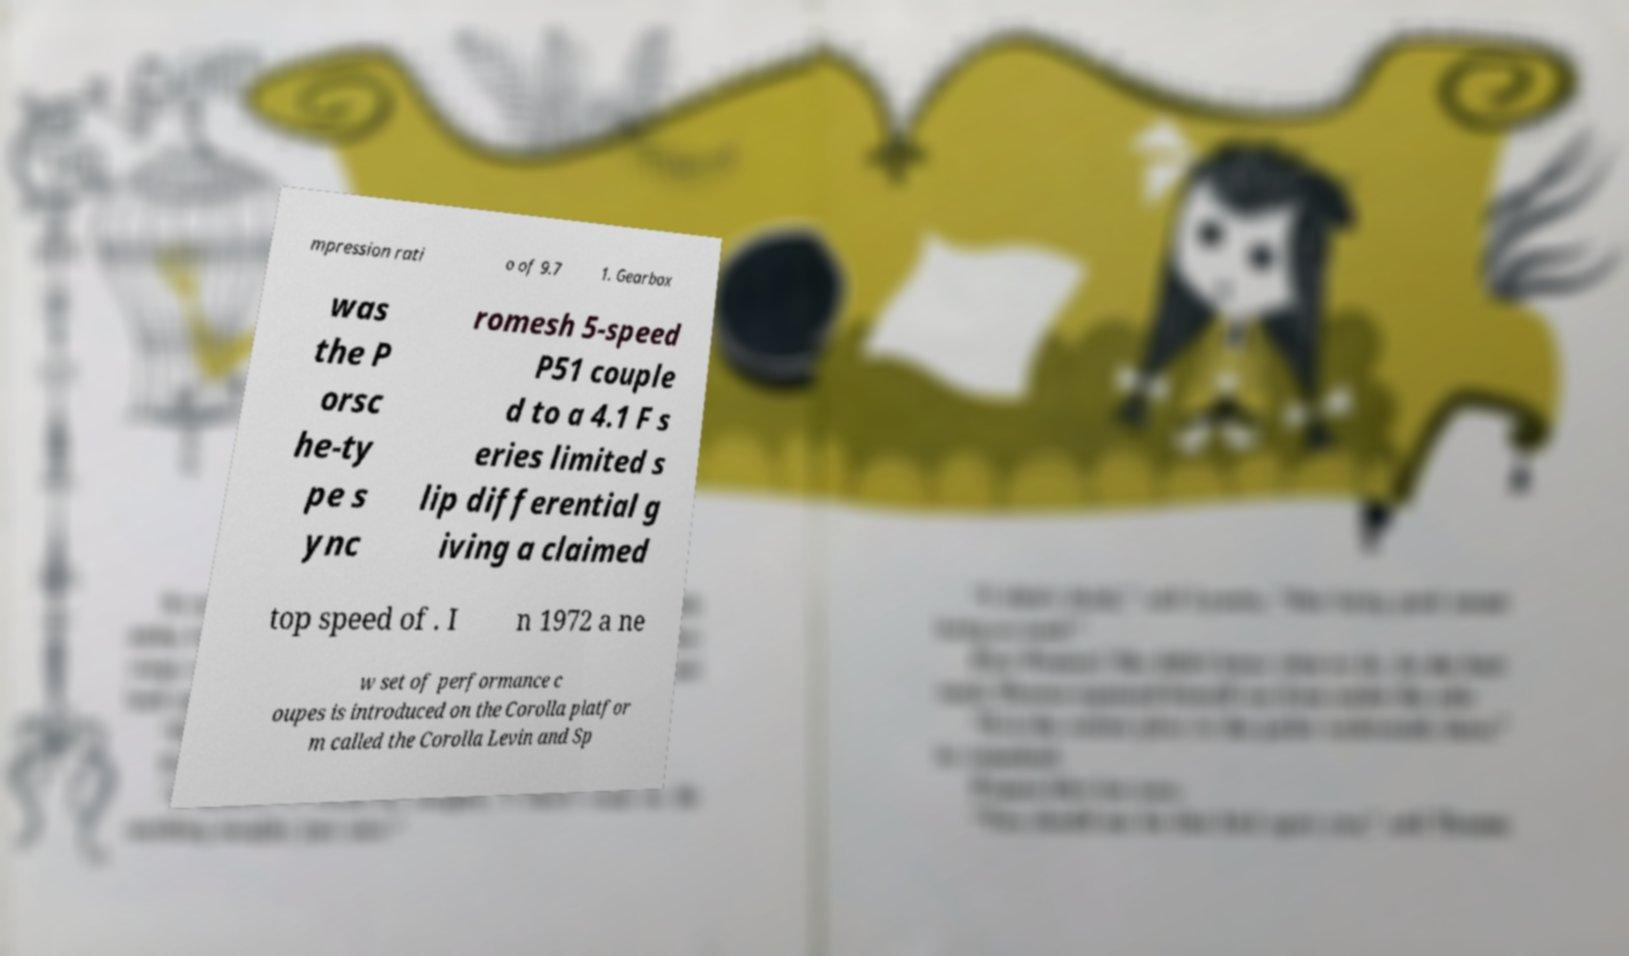Please identify and transcribe the text found in this image. mpression rati o of 9.7 1. Gearbox was the P orsc he-ty pe s ync romesh 5-speed P51 couple d to a 4.1 F s eries limited s lip differential g iving a claimed top speed of . I n 1972 a ne w set of performance c oupes is introduced on the Corolla platfor m called the Corolla Levin and Sp 